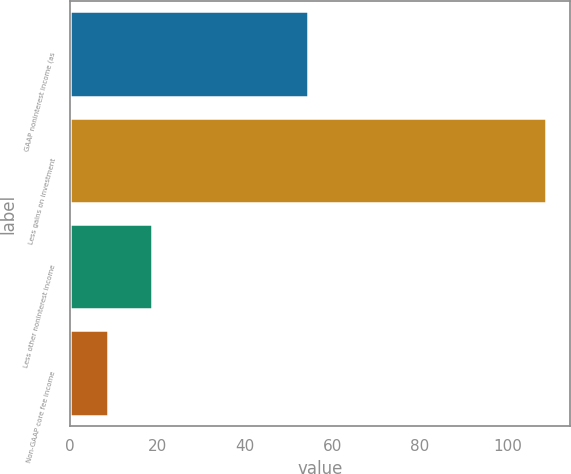Convert chart. <chart><loc_0><loc_0><loc_500><loc_500><bar_chart><fcel>GAAP noninterest income (as<fcel>Less gains on investment<fcel>Less other noninterest income<fcel>Non-GAAP core fee income<nl><fcel>54.5<fcel>108.9<fcel>18.72<fcel>8.7<nl></chart> 